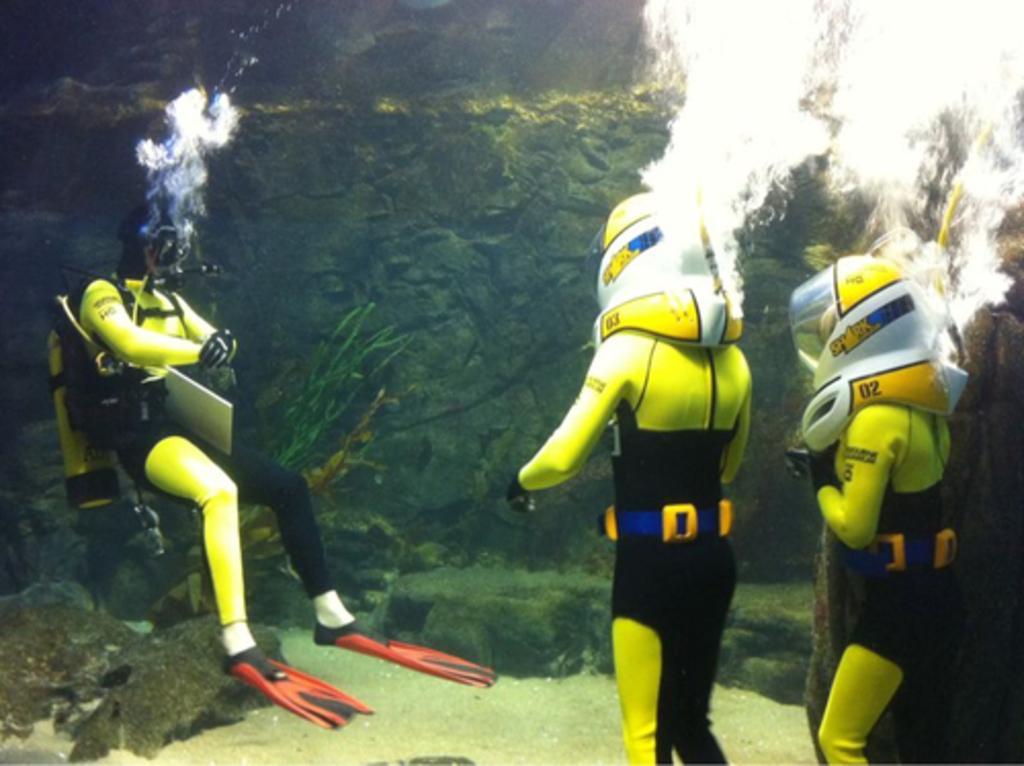Could you give a brief overview of what you see in this image? In this image we can see people doing scuba diving in the water. At the bottom there are water plants. 